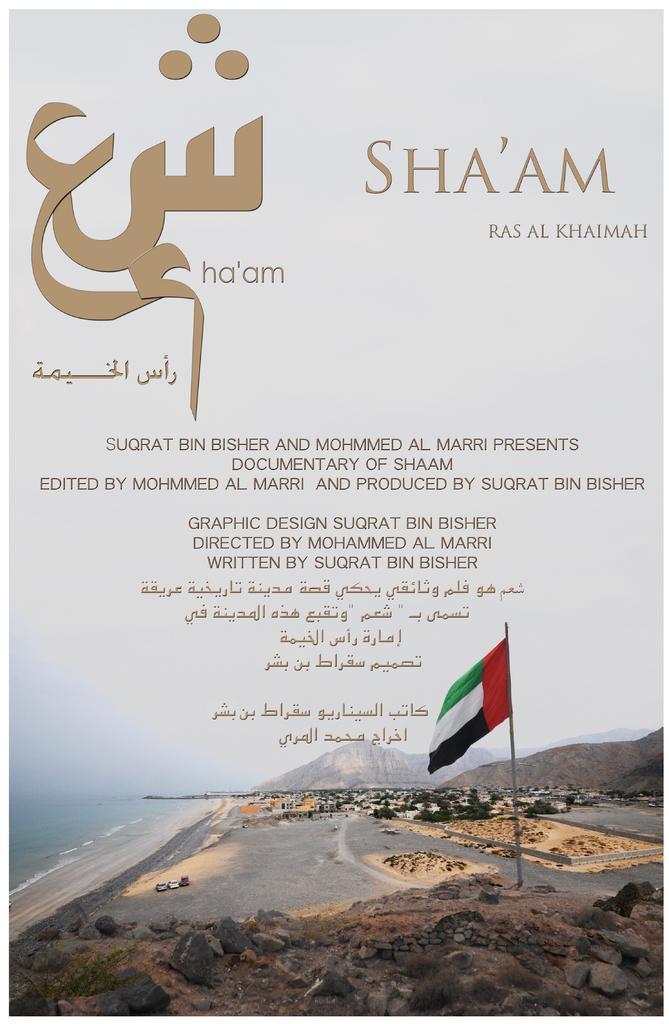What can be seen written on the image? There are texts written on the image. What symbol is present in the image? There is a flag in the image. What type of pathway is visible in the image? There is a road in the image. What natural feature can be seen in the background of the image? There are mountains visible in the background of the image. What type of ground surface is present in the front of the image? There are stones on the ground in the front of the image. What type of account is being discussed in the image? There is no account being discussed in the image; it features texts, a flag, a road, mountains, and stones on the ground. How many bricks are visible in the image? There are no bricks present in the image. 